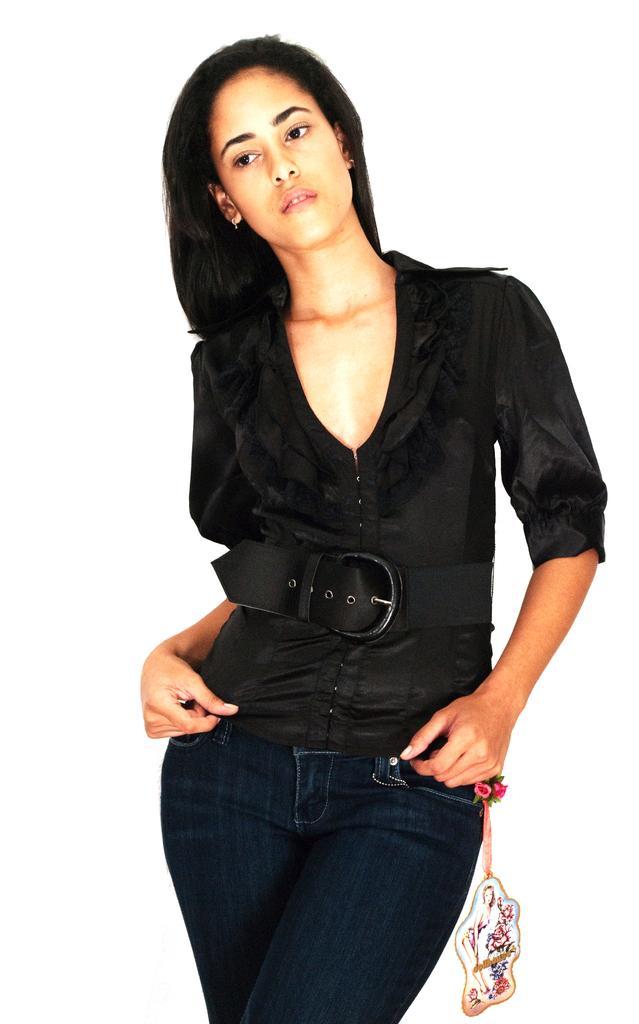Describe this image in one or two sentences. In the foreground of this image, there is a woman standing and wearing a black shirt and there is a tag tied to the jeans and there is a white background. 